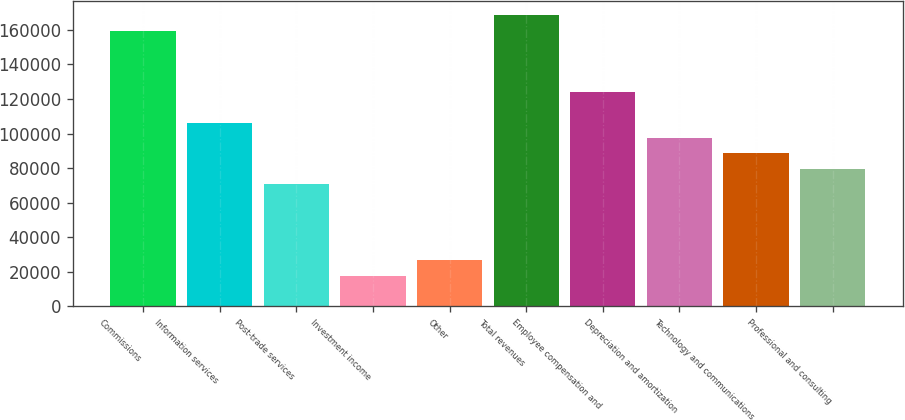Convert chart to OTSL. <chart><loc_0><loc_0><loc_500><loc_500><bar_chart><fcel>Commissions<fcel>Information services<fcel>Post-trade services<fcel>Investment income<fcel>Other<fcel>Total revenues<fcel>Employee compensation and<fcel>Depreciation and amortization<fcel>Technology and communications<fcel>Professional and consulting<nl><fcel>159431<fcel>106287<fcel>70858.5<fcel>17715.2<fcel>26572.4<fcel>168288<fcel>124002<fcel>97430.2<fcel>88573<fcel>79715.8<nl></chart> 